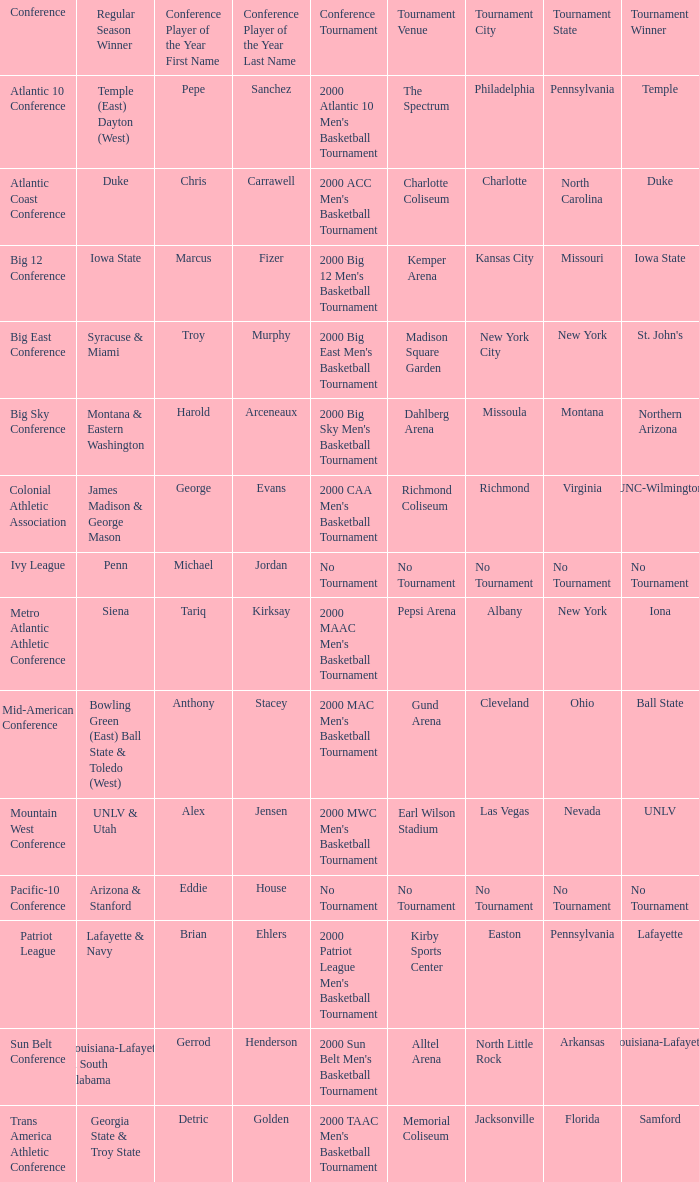In which city and venue was the 2000 mwc men's basketball tournament held? Earl Wilson Stadium ( Las Vegas, Nevada ). 